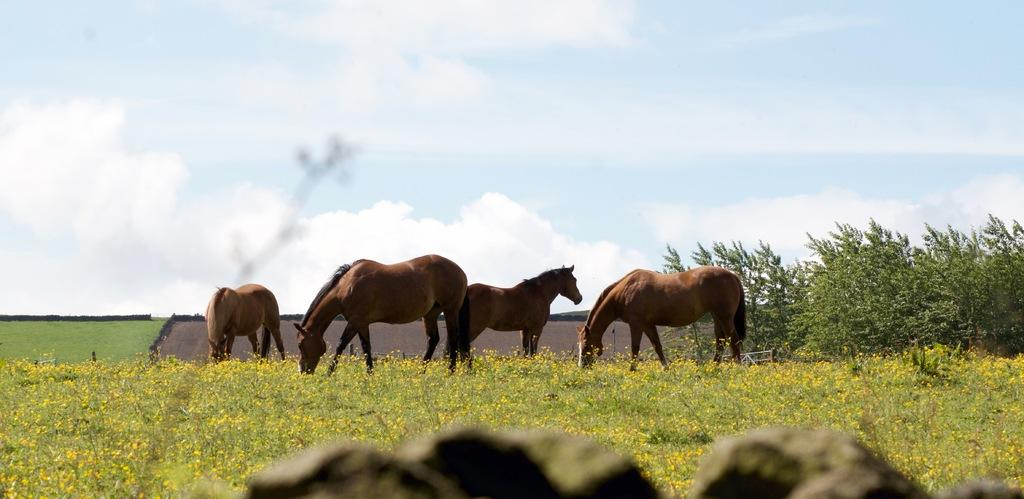What type of living organisms can be seen in the image? Plants, flowers, and horses are visible in the image. What other natural elements can be seen in the image? Trees and grass are visible in the image. What is visible in the background of the image? The sky is visible in the background of the image. What can be observed in the sky? Clouds are present in the sky. Where is the bucket located in the image? There is no bucket present in the image. What type of chicken can be seen interacting with the horses in the image? There are no chickens present in the image; it features plants, flowers, trees, grass, and horses. 